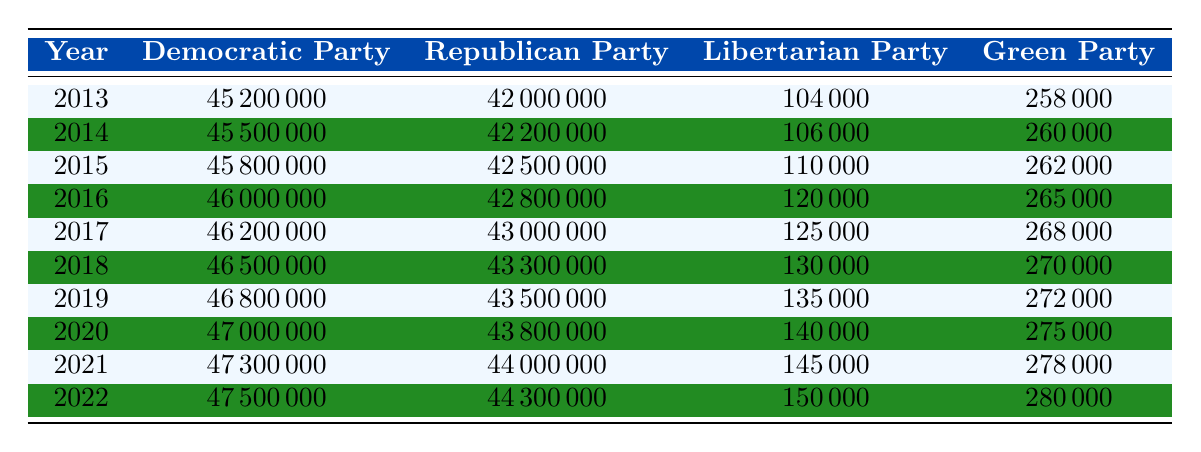What was the membership of the Democratic Party in 2016? According to the table, in the year 2016, the membership of the Democratic Party was listed as 46,000,000.
Answer: 46,000,000 Which party had the highest membership in 2019? By checking the table for the year 2019, the Democratic Party had the highest membership at 46,800,000, compared to the Republican Party with 43,500,000, Libertarian Party with 135,000, and Green Party with 272,000.
Answer: Democratic Party What is the difference in membership between the Republican Party in 2015 and 2022? The table shows the Republican Party had 42,500,000 members in 2015 and 44,300,000 in 2022. The difference is calculated as 44,300,000 - 42,500,000 = 1,800,000.
Answer: 1,800,000 Did the Libertarian Party's membership increase every year from 2013 to 2022? Looking at the values in the table for the Libertarian Party from 2013 (104,000) to 2022 (150,000), it is evident that the membership increased each year: 106,000 (2014), 110,000 (2015), 120,000 (2016), 125,000 (2017), 130,000 (2018), 135,000 (2019), 140,000 (2020), 145,000 (2021), and finally 150,000 (2022). Therefore, the statement is true.
Answer: Yes What was the average membership of the Green Party from 2013 to 2022? To find the average membership of the Green Party, we sum the memberships for each year from 2013 to 2022: 258,000 (2013) + 260,000 + 262,000 + 265,000 + 268,000 + 270,000 + 272,000 + 275,000 + 278,000 + 280,000 = 2,645,000. There are 10 years, so the average is 2,645,000 / 10 = 264,500.
Answer: 264,500 